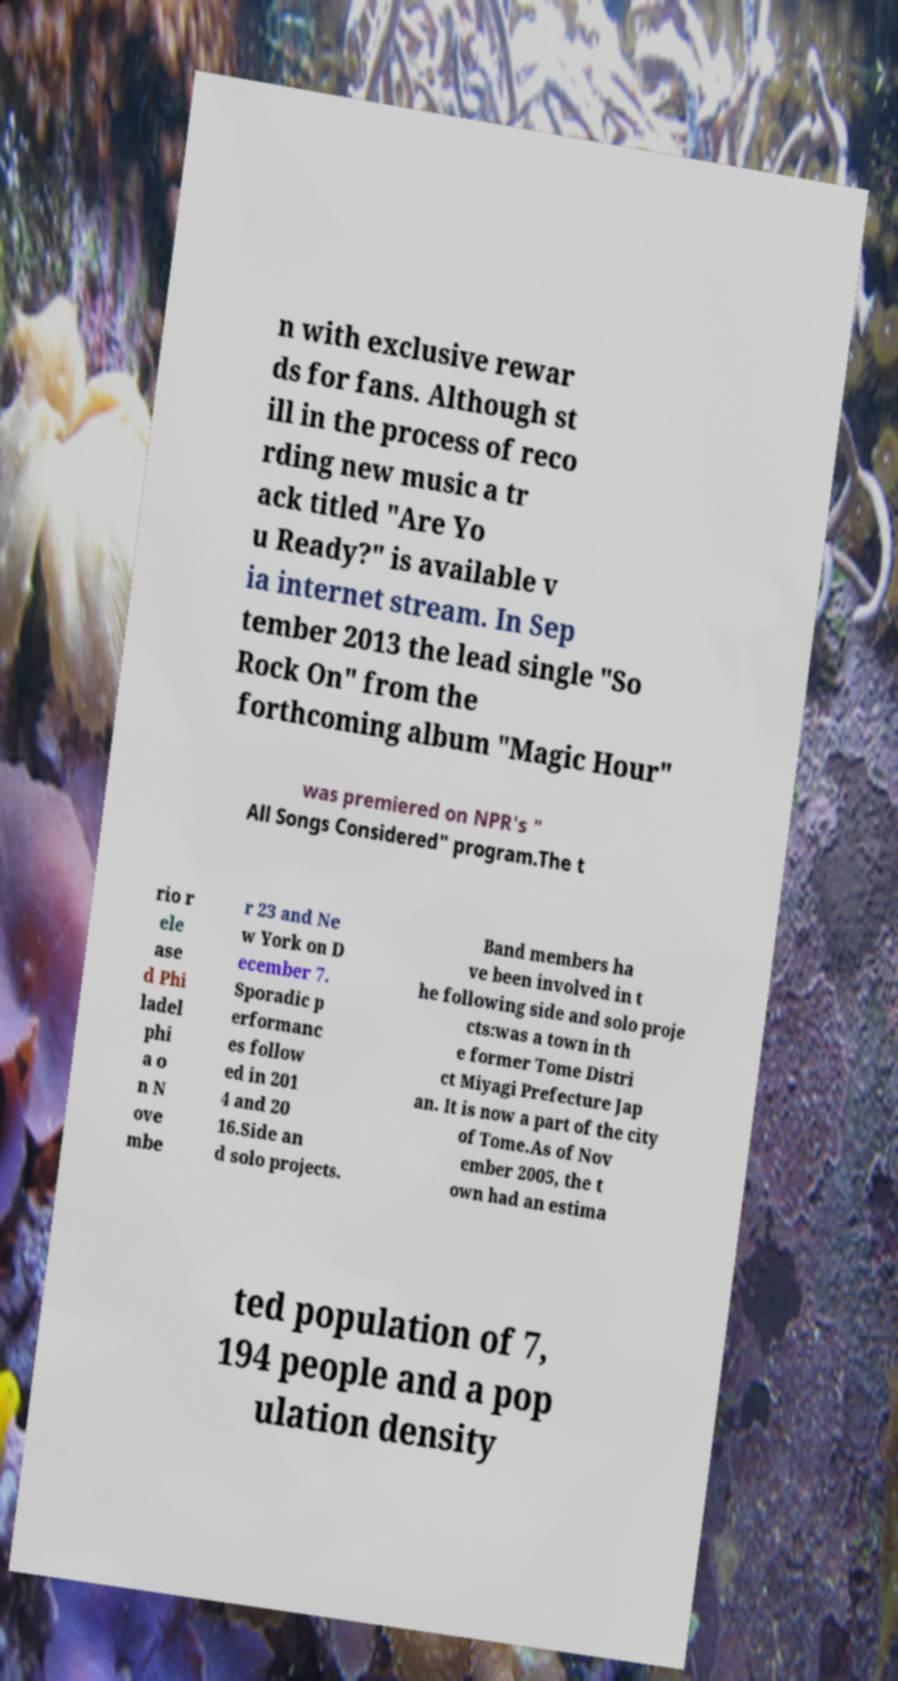Could you extract and type out the text from this image? n with exclusive rewar ds for fans. Although st ill in the process of reco rding new music a tr ack titled "Are Yo u Ready?" is available v ia internet stream. In Sep tember 2013 the lead single "So Rock On" from the forthcoming album "Magic Hour" was premiered on NPR's " All Songs Considered" program.The t rio r ele ase d Phi ladel phi a o n N ove mbe r 23 and Ne w York on D ecember 7. Sporadic p erformanc es follow ed in 201 4 and 20 16.Side an d solo projects. Band members ha ve been involved in t he following side and solo proje cts:was a town in th e former Tome Distri ct Miyagi Prefecture Jap an. It is now a part of the city of Tome.As of Nov ember 2005, the t own had an estima ted population of 7, 194 people and a pop ulation density 